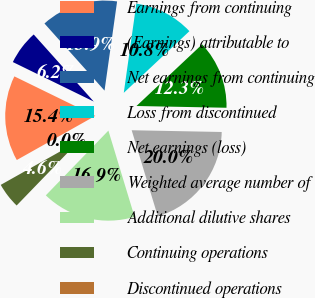<chart> <loc_0><loc_0><loc_500><loc_500><pie_chart><fcel>Earnings from continuing<fcel>(Earnings) attributable to<fcel>Net earnings from continuing<fcel>Loss from discontinued<fcel>Net earnings (loss)<fcel>Weighted average number of<fcel>Additional dilutive shares<fcel>Continuing operations<fcel>Discontinued operations<nl><fcel>15.38%<fcel>6.15%<fcel>13.85%<fcel>10.77%<fcel>12.31%<fcel>20.0%<fcel>16.92%<fcel>4.62%<fcel>0.0%<nl></chart> 